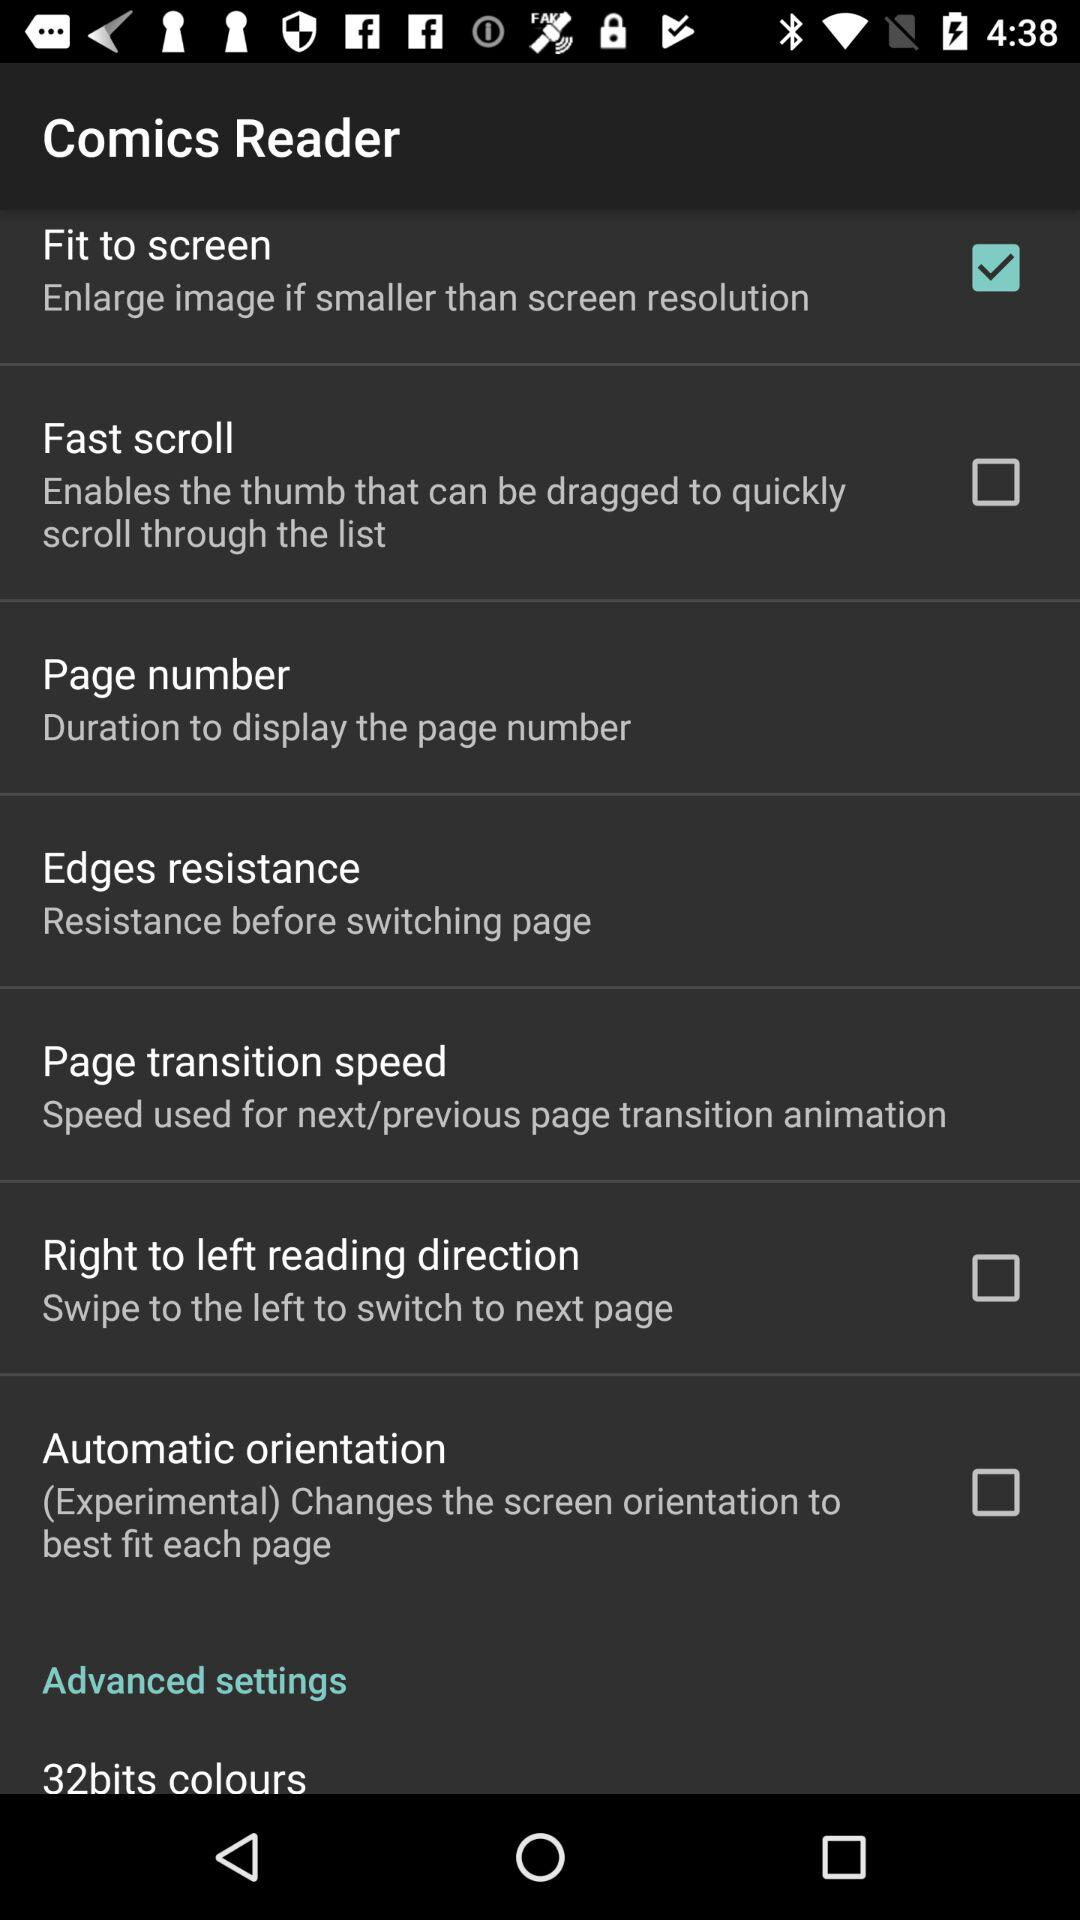What is the status of "Fit to screen"? The status is "on". 